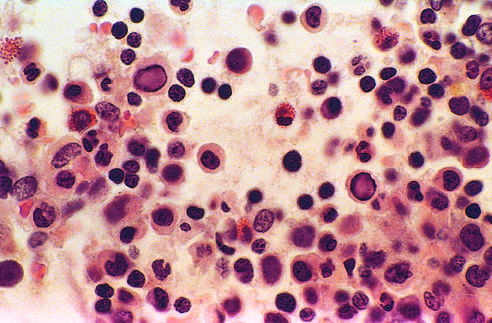s this bone marrow from an infant infected with parvovirus b19?
Answer the question using a single word or phrase. Yes 